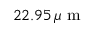<formula> <loc_0><loc_0><loc_500><loc_500>2 2 . 9 5 \, \mu m</formula> 